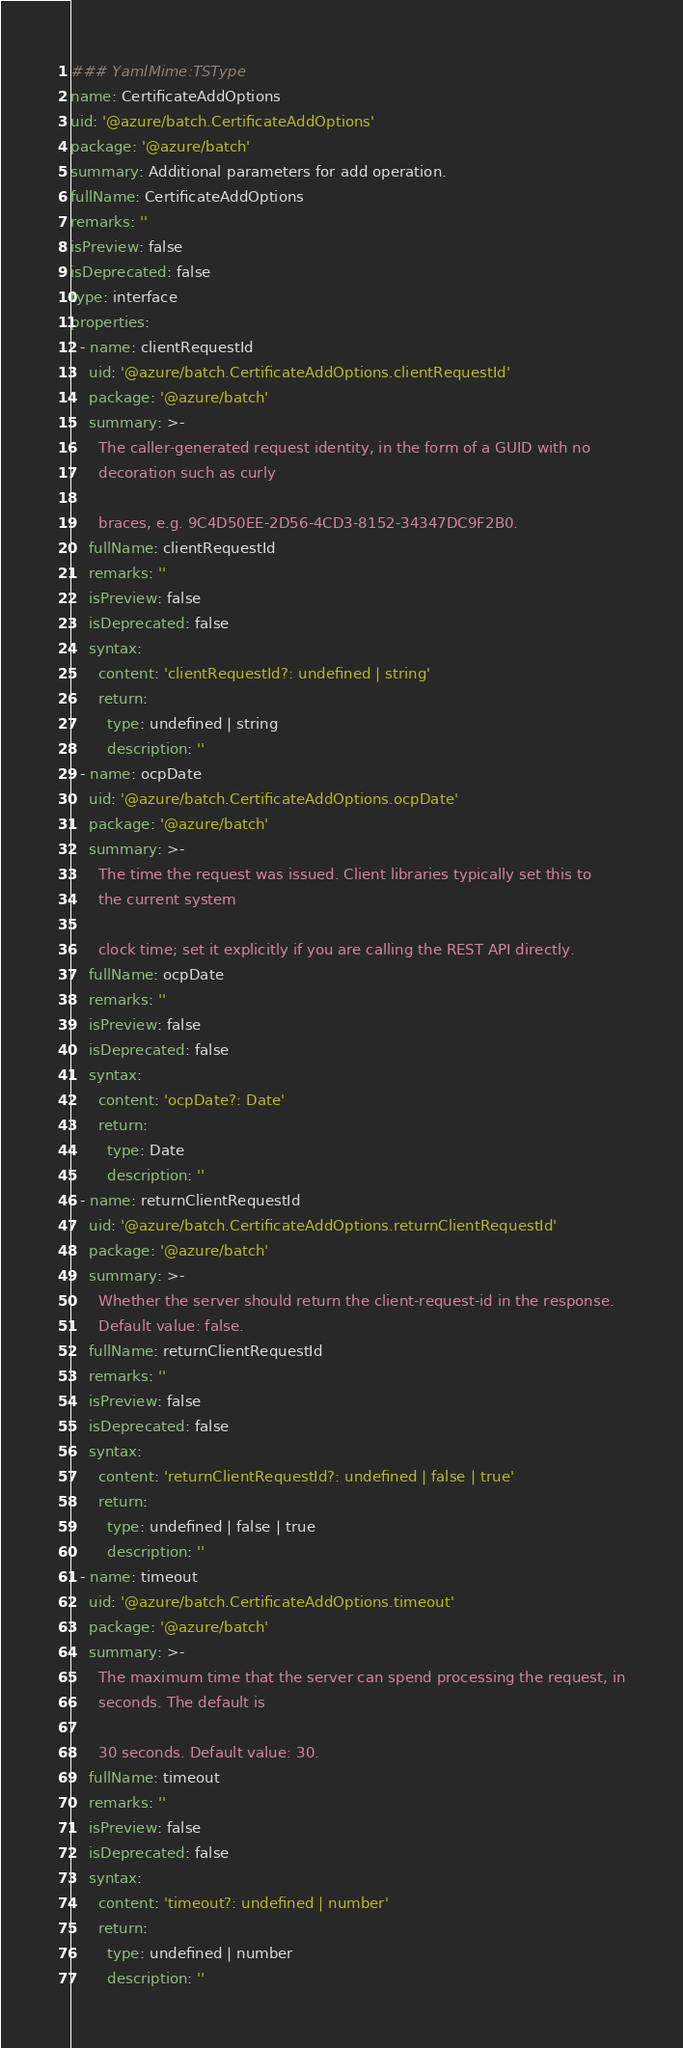<code> <loc_0><loc_0><loc_500><loc_500><_YAML_>### YamlMime:TSType
name: CertificateAddOptions
uid: '@azure/batch.CertificateAddOptions'
package: '@azure/batch'
summary: Additional parameters for add operation.
fullName: CertificateAddOptions
remarks: ''
isPreview: false
isDeprecated: false
type: interface
properties:
  - name: clientRequestId
    uid: '@azure/batch.CertificateAddOptions.clientRequestId'
    package: '@azure/batch'
    summary: >-
      The caller-generated request identity, in the form of a GUID with no
      decoration such as curly

      braces, e.g. 9C4D50EE-2D56-4CD3-8152-34347DC9F2B0.
    fullName: clientRequestId
    remarks: ''
    isPreview: false
    isDeprecated: false
    syntax:
      content: 'clientRequestId?: undefined | string'
      return:
        type: undefined | string
        description: ''
  - name: ocpDate
    uid: '@azure/batch.CertificateAddOptions.ocpDate'
    package: '@azure/batch'
    summary: >-
      The time the request was issued. Client libraries typically set this to
      the current system

      clock time; set it explicitly if you are calling the REST API directly.
    fullName: ocpDate
    remarks: ''
    isPreview: false
    isDeprecated: false
    syntax:
      content: 'ocpDate?: Date'
      return:
        type: Date
        description: ''
  - name: returnClientRequestId
    uid: '@azure/batch.CertificateAddOptions.returnClientRequestId'
    package: '@azure/batch'
    summary: >-
      Whether the server should return the client-request-id in the response.
      Default value: false.
    fullName: returnClientRequestId
    remarks: ''
    isPreview: false
    isDeprecated: false
    syntax:
      content: 'returnClientRequestId?: undefined | false | true'
      return:
        type: undefined | false | true
        description: ''
  - name: timeout
    uid: '@azure/batch.CertificateAddOptions.timeout'
    package: '@azure/batch'
    summary: >-
      The maximum time that the server can spend processing the request, in
      seconds. The default is

      30 seconds. Default value: 30.
    fullName: timeout
    remarks: ''
    isPreview: false
    isDeprecated: false
    syntax:
      content: 'timeout?: undefined | number'
      return:
        type: undefined | number
        description: ''
</code> 